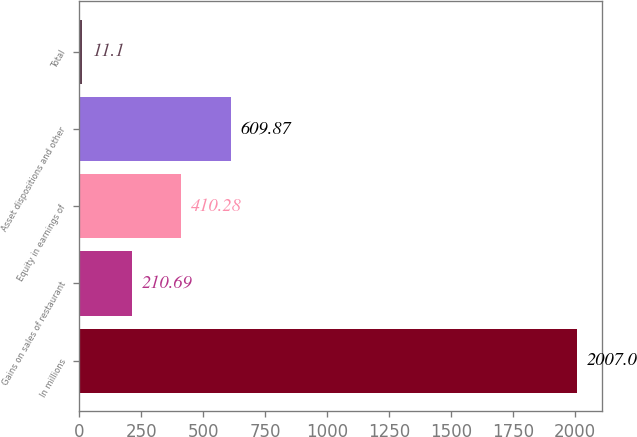Convert chart to OTSL. <chart><loc_0><loc_0><loc_500><loc_500><bar_chart><fcel>In millions<fcel>Gains on sales of restaurant<fcel>Equity in earnings of<fcel>Asset dispositions and other<fcel>Total<nl><fcel>2007<fcel>210.69<fcel>410.28<fcel>609.87<fcel>11.1<nl></chart> 